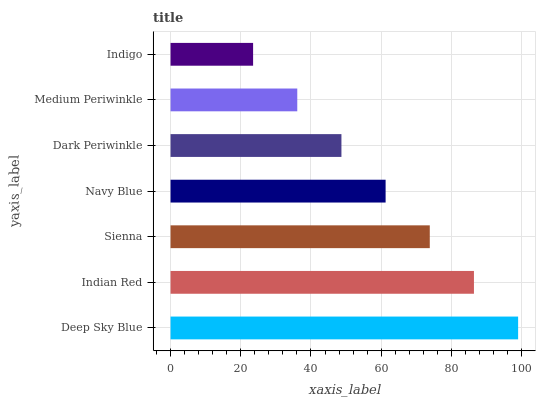Is Indigo the minimum?
Answer yes or no. Yes. Is Deep Sky Blue the maximum?
Answer yes or no. Yes. Is Indian Red the minimum?
Answer yes or no. No. Is Indian Red the maximum?
Answer yes or no. No. Is Deep Sky Blue greater than Indian Red?
Answer yes or no. Yes. Is Indian Red less than Deep Sky Blue?
Answer yes or no. Yes. Is Indian Red greater than Deep Sky Blue?
Answer yes or no. No. Is Deep Sky Blue less than Indian Red?
Answer yes or no. No. Is Navy Blue the high median?
Answer yes or no. Yes. Is Navy Blue the low median?
Answer yes or no. Yes. Is Dark Periwinkle the high median?
Answer yes or no. No. Is Indian Red the low median?
Answer yes or no. No. 